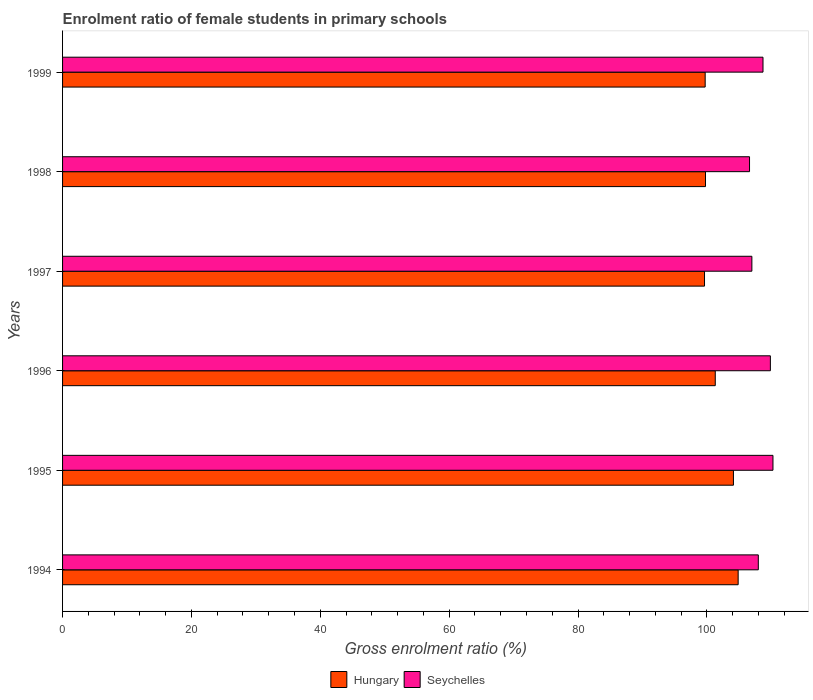How many groups of bars are there?
Your answer should be compact. 6. Are the number of bars per tick equal to the number of legend labels?
Your response must be concise. Yes. How many bars are there on the 3rd tick from the top?
Make the answer very short. 2. What is the label of the 4th group of bars from the top?
Make the answer very short. 1996. What is the enrolment ratio of female students in primary schools in Hungary in 1995?
Give a very brief answer. 104.11. Across all years, what is the maximum enrolment ratio of female students in primary schools in Hungary?
Offer a very short reply. 104.84. Across all years, what is the minimum enrolment ratio of female students in primary schools in Hungary?
Ensure brevity in your answer.  99.62. In which year was the enrolment ratio of female students in primary schools in Hungary maximum?
Provide a short and direct response. 1994. What is the total enrolment ratio of female students in primary schools in Seychelles in the graph?
Offer a terse response. 650.34. What is the difference between the enrolment ratio of female students in primary schools in Hungary in 1994 and that in 1996?
Make the answer very short. 3.55. What is the difference between the enrolment ratio of female students in primary schools in Hungary in 1996 and the enrolment ratio of female students in primary schools in Seychelles in 1999?
Offer a very short reply. -7.41. What is the average enrolment ratio of female students in primary schools in Seychelles per year?
Provide a short and direct response. 108.39. In the year 1994, what is the difference between the enrolment ratio of female students in primary schools in Hungary and enrolment ratio of female students in primary schools in Seychelles?
Your response must be concise. -3.13. In how many years, is the enrolment ratio of female students in primary schools in Hungary greater than 96 %?
Your answer should be very brief. 6. What is the ratio of the enrolment ratio of female students in primary schools in Seychelles in 1994 to that in 1997?
Give a very brief answer. 1.01. What is the difference between the highest and the second highest enrolment ratio of female students in primary schools in Seychelles?
Your response must be concise. 0.4. What is the difference between the highest and the lowest enrolment ratio of female students in primary schools in Seychelles?
Give a very brief answer. 3.64. Is the sum of the enrolment ratio of female students in primary schools in Seychelles in 1996 and 1998 greater than the maximum enrolment ratio of female students in primary schools in Hungary across all years?
Ensure brevity in your answer.  Yes. What does the 1st bar from the top in 1994 represents?
Provide a succinct answer. Seychelles. What does the 2nd bar from the bottom in 1995 represents?
Ensure brevity in your answer.  Seychelles. Are all the bars in the graph horizontal?
Give a very brief answer. Yes. What is the difference between two consecutive major ticks on the X-axis?
Make the answer very short. 20. Does the graph contain any zero values?
Provide a short and direct response. No. Does the graph contain grids?
Keep it short and to the point. No. Where does the legend appear in the graph?
Make the answer very short. Bottom center. How many legend labels are there?
Your response must be concise. 2. What is the title of the graph?
Provide a short and direct response. Enrolment ratio of female students in primary schools. What is the label or title of the Y-axis?
Your answer should be compact. Years. What is the Gross enrolment ratio (%) of Hungary in 1994?
Ensure brevity in your answer.  104.84. What is the Gross enrolment ratio (%) of Seychelles in 1994?
Keep it short and to the point. 107.97. What is the Gross enrolment ratio (%) in Hungary in 1995?
Keep it short and to the point. 104.11. What is the Gross enrolment ratio (%) of Seychelles in 1995?
Provide a short and direct response. 110.25. What is the Gross enrolment ratio (%) in Hungary in 1996?
Offer a terse response. 101.29. What is the Gross enrolment ratio (%) in Seychelles in 1996?
Give a very brief answer. 109.84. What is the Gross enrolment ratio (%) in Hungary in 1997?
Ensure brevity in your answer.  99.62. What is the Gross enrolment ratio (%) in Seychelles in 1997?
Make the answer very short. 106.97. What is the Gross enrolment ratio (%) of Hungary in 1998?
Provide a succinct answer. 99.78. What is the Gross enrolment ratio (%) in Seychelles in 1998?
Keep it short and to the point. 106.61. What is the Gross enrolment ratio (%) in Hungary in 1999?
Ensure brevity in your answer.  99.73. What is the Gross enrolment ratio (%) in Seychelles in 1999?
Make the answer very short. 108.7. Across all years, what is the maximum Gross enrolment ratio (%) of Hungary?
Your answer should be very brief. 104.84. Across all years, what is the maximum Gross enrolment ratio (%) in Seychelles?
Make the answer very short. 110.25. Across all years, what is the minimum Gross enrolment ratio (%) of Hungary?
Your answer should be compact. 99.62. Across all years, what is the minimum Gross enrolment ratio (%) of Seychelles?
Your answer should be very brief. 106.61. What is the total Gross enrolment ratio (%) in Hungary in the graph?
Offer a terse response. 609.37. What is the total Gross enrolment ratio (%) in Seychelles in the graph?
Your answer should be very brief. 650.34. What is the difference between the Gross enrolment ratio (%) in Hungary in 1994 and that in 1995?
Offer a very short reply. 0.73. What is the difference between the Gross enrolment ratio (%) in Seychelles in 1994 and that in 1995?
Offer a very short reply. -2.27. What is the difference between the Gross enrolment ratio (%) of Hungary in 1994 and that in 1996?
Give a very brief answer. 3.55. What is the difference between the Gross enrolment ratio (%) of Seychelles in 1994 and that in 1996?
Give a very brief answer. -1.87. What is the difference between the Gross enrolment ratio (%) in Hungary in 1994 and that in 1997?
Offer a terse response. 5.22. What is the difference between the Gross enrolment ratio (%) of Hungary in 1994 and that in 1998?
Provide a succinct answer. 5.07. What is the difference between the Gross enrolment ratio (%) of Seychelles in 1994 and that in 1998?
Your response must be concise. 1.36. What is the difference between the Gross enrolment ratio (%) of Hungary in 1994 and that in 1999?
Provide a succinct answer. 5.12. What is the difference between the Gross enrolment ratio (%) of Seychelles in 1994 and that in 1999?
Provide a succinct answer. -0.73. What is the difference between the Gross enrolment ratio (%) of Hungary in 1995 and that in 1996?
Your response must be concise. 2.82. What is the difference between the Gross enrolment ratio (%) in Seychelles in 1995 and that in 1996?
Offer a terse response. 0.4. What is the difference between the Gross enrolment ratio (%) of Hungary in 1995 and that in 1997?
Provide a short and direct response. 4.49. What is the difference between the Gross enrolment ratio (%) in Seychelles in 1995 and that in 1997?
Your response must be concise. 3.27. What is the difference between the Gross enrolment ratio (%) of Hungary in 1995 and that in 1998?
Your response must be concise. 4.34. What is the difference between the Gross enrolment ratio (%) in Seychelles in 1995 and that in 1998?
Ensure brevity in your answer.  3.64. What is the difference between the Gross enrolment ratio (%) of Hungary in 1995 and that in 1999?
Your response must be concise. 4.39. What is the difference between the Gross enrolment ratio (%) in Seychelles in 1995 and that in 1999?
Offer a very short reply. 1.55. What is the difference between the Gross enrolment ratio (%) of Hungary in 1996 and that in 1997?
Offer a very short reply. 1.67. What is the difference between the Gross enrolment ratio (%) in Seychelles in 1996 and that in 1997?
Ensure brevity in your answer.  2.87. What is the difference between the Gross enrolment ratio (%) in Hungary in 1996 and that in 1998?
Give a very brief answer. 1.52. What is the difference between the Gross enrolment ratio (%) in Seychelles in 1996 and that in 1998?
Your answer should be compact. 3.23. What is the difference between the Gross enrolment ratio (%) in Hungary in 1996 and that in 1999?
Your answer should be very brief. 1.57. What is the difference between the Gross enrolment ratio (%) in Seychelles in 1996 and that in 1999?
Offer a terse response. 1.14. What is the difference between the Gross enrolment ratio (%) in Hungary in 1997 and that in 1998?
Your answer should be very brief. -0.15. What is the difference between the Gross enrolment ratio (%) in Seychelles in 1997 and that in 1998?
Offer a terse response. 0.36. What is the difference between the Gross enrolment ratio (%) in Hungary in 1997 and that in 1999?
Provide a succinct answer. -0.1. What is the difference between the Gross enrolment ratio (%) of Seychelles in 1997 and that in 1999?
Ensure brevity in your answer.  -1.73. What is the difference between the Gross enrolment ratio (%) of Hungary in 1998 and that in 1999?
Ensure brevity in your answer.  0.05. What is the difference between the Gross enrolment ratio (%) of Seychelles in 1998 and that in 1999?
Provide a short and direct response. -2.09. What is the difference between the Gross enrolment ratio (%) in Hungary in 1994 and the Gross enrolment ratio (%) in Seychelles in 1995?
Provide a succinct answer. -5.4. What is the difference between the Gross enrolment ratio (%) in Hungary in 1994 and the Gross enrolment ratio (%) in Seychelles in 1996?
Provide a succinct answer. -5. What is the difference between the Gross enrolment ratio (%) of Hungary in 1994 and the Gross enrolment ratio (%) of Seychelles in 1997?
Your response must be concise. -2.13. What is the difference between the Gross enrolment ratio (%) of Hungary in 1994 and the Gross enrolment ratio (%) of Seychelles in 1998?
Give a very brief answer. -1.77. What is the difference between the Gross enrolment ratio (%) of Hungary in 1994 and the Gross enrolment ratio (%) of Seychelles in 1999?
Your answer should be compact. -3.86. What is the difference between the Gross enrolment ratio (%) of Hungary in 1995 and the Gross enrolment ratio (%) of Seychelles in 1996?
Make the answer very short. -5.73. What is the difference between the Gross enrolment ratio (%) in Hungary in 1995 and the Gross enrolment ratio (%) in Seychelles in 1997?
Offer a very short reply. -2.86. What is the difference between the Gross enrolment ratio (%) of Hungary in 1995 and the Gross enrolment ratio (%) of Seychelles in 1998?
Offer a very short reply. -2.5. What is the difference between the Gross enrolment ratio (%) of Hungary in 1995 and the Gross enrolment ratio (%) of Seychelles in 1999?
Your response must be concise. -4.59. What is the difference between the Gross enrolment ratio (%) of Hungary in 1996 and the Gross enrolment ratio (%) of Seychelles in 1997?
Your answer should be compact. -5.68. What is the difference between the Gross enrolment ratio (%) in Hungary in 1996 and the Gross enrolment ratio (%) in Seychelles in 1998?
Keep it short and to the point. -5.32. What is the difference between the Gross enrolment ratio (%) of Hungary in 1996 and the Gross enrolment ratio (%) of Seychelles in 1999?
Offer a terse response. -7.41. What is the difference between the Gross enrolment ratio (%) of Hungary in 1997 and the Gross enrolment ratio (%) of Seychelles in 1998?
Give a very brief answer. -6.99. What is the difference between the Gross enrolment ratio (%) in Hungary in 1997 and the Gross enrolment ratio (%) in Seychelles in 1999?
Give a very brief answer. -9.08. What is the difference between the Gross enrolment ratio (%) of Hungary in 1998 and the Gross enrolment ratio (%) of Seychelles in 1999?
Your answer should be compact. -8.92. What is the average Gross enrolment ratio (%) of Hungary per year?
Provide a short and direct response. 101.56. What is the average Gross enrolment ratio (%) of Seychelles per year?
Keep it short and to the point. 108.39. In the year 1994, what is the difference between the Gross enrolment ratio (%) in Hungary and Gross enrolment ratio (%) in Seychelles?
Make the answer very short. -3.13. In the year 1995, what is the difference between the Gross enrolment ratio (%) in Hungary and Gross enrolment ratio (%) in Seychelles?
Your answer should be very brief. -6.13. In the year 1996, what is the difference between the Gross enrolment ratio (%) of Hungary and Gross enrolment ratio (%) of Seychelles?
Your answer should be very brief. -8.55. In the year 1997, what is the difference between the Gross enrolment ratio (%) in Hungary and Gross enrolment ratio (%) in Seychelles?
Give a very brief answer. -7.35. In the year 1998, what is the difference between the Gross enrolment ratio (%) in Hungary and Gross enrolment ratio (%) in Seychelles?
Keep it short and to the point. -6.83. In the year 1999, what is the difference between the Gross enrolment ratio (%) in Hungary and Gross enrolment ratio (%) in Seychelles?
Offer a very short reply. -8.97. What is the ratio of the Gross enrolment ratio (%) of Hungary in 1994 to that in 1995?
Offer a terse response. 1.01. What is the ratio of the Gross enrolment ratio (%) of Seychelles in 1994 to that in 1995?
Provide a short and direct response. 0.98. What is the ratio of the Gross enrolment ratio (%) of Hungary in 1994 to that in 1996?
Offer a very short reply. 1.04. What is the ratio of the Gross enrolment ratio (%) in Hungary in 1994 to that in 1997?
Ensure brevity in your answer.  1.05. What is the ratio of the Gross enrolment ratio (%) of Seychelles in 1994 to that in 1997?
Your answer should be compact. 1.01. What is the ratio of the Gross enrolment ratio (%) in Hungary in 1994 to that in 1998?
Keep it short and to the point. 1.05. What is the ratio of the Gross enrolment ratio (%) of Seychelles in 1994 to that in 1998?
Offer a very short reply. 1.01. What is the ratio of the Gross enrolment ratio (%) of Hungary in 1994 to that in 1999?
Give a very brief answer. 1.05. What is the ratio of the Gross enrolment ratio (%) of Seychelles in 1994 to that in 1999?
Your answer should be very brief. 0.99. What is the ratio of the Gross enrolment ratio (%) in Hungary in 1995 to that in 1996?
Give a very brief answer. 1.03. What is the ratio of the Gross enrolment ratio (%) of Hungary in 1995 to that in 1997?
Provide a short and direct response. 1.05. What is the ratio of the Gross enrolment ratio (%) of Seychelles in 1995 to that in 1997?
Keep it short and to the point. 1.03. What is the ratio of the Gross enrolment ratio (%) in Hungary in 1995 to that in 1998?
Give a very brief answer. 1.04. What is the ratio of the Gross enrolment ratio (%) of Seychelles in 1995 to that in 1998?
Provide a succinct answer. 1.03. What is the ratio of the Gross enrolment ratio (%) of Hungary in 1995 to that in 1999?
Keep it short and to the point. 1.04. What is the ratio of the Gross enrolment ratio (%) in Seychelles in 1995 to that in 1999?
Keep it short and to the point. 1.01. What is the ratio of the Gross enrolment ratio (%) in Hungary in 1996 to that in 1997?
Your answer should be very brief. 1.02. What is the ratio of the Gross enrolment ratio (%) of Seychelles in 1996 to that in 1997?
Your response must be concise. 1.03. What is the ratio of the Gross enrolment ratio (%) of Hungary in 1996 to that in 1998?
Your response must be concise. 1.02. What is the ratio of the Gross enrolment ratio (%) of Seychelles in 1996 to that in 1998?
Your answer should be very brief. 1.03. What is the ratio of the Gross enrolment ratio (%) in Hungary in 1996 to that in 1999?
Your answer should be very brief. 1.02. What is the ratio of the Gross enrolment ratio (%) of Seychelles in 1996 to that in 1999?
Offer a very short reply. 1.01. What is the ratio of the Gross enrolment ratio (%) of Hungary in 1997 to that in 1999?
Your answer should be very brief. 1. What is the ratio of the Gross enrolment ratio (%) in Seychelles in 1997 to that in 1999?
Offer a very short reply. 0.98. What is the ratio of the Gross enrolment ratio (%) in Hungary in 1998 to that in 1999?
Your response must be concise. 1. What is the ratio of the Gross enrolment ratio (%) in Seychelles in 1998 to that in 1999?
Offer a terse response. 0.98. What is the difference between the highest and the second highest Gross enrolment ratio (%) of Hungary?
Your answer should be compact. 0.73. What is the difference between the highest and the second highest Gross enrolment ratio (%) in Seychelles?
Offer a terse response. 0.4. What is the difference between the highest and the lowest Gross enrolment ratio (%) in Hungary?
Provide a short and direct response. 5.22. What is the difference between the highest and the lowest Gross enrolment ratio (%) in Seychelles?
Your answer should be compact. 3.64. 